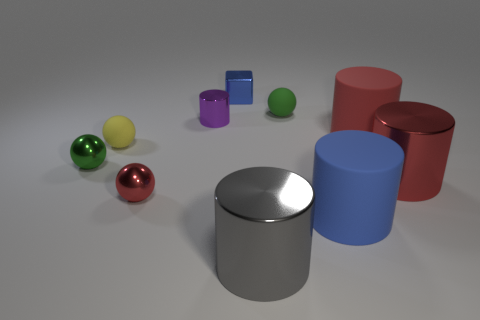How many objects are either large objects or red objects behind the big red shiny thing?
Offer a terse response. 4. What is the material of the purple cylinder that is the same size as the cube?
Offer a very short reply. Metal. Is the material of the yellow sphere the same as the red sphere?
Your response must be concise. No. There is a cylinder that is both behind the big red metallic cylinder and in front of the small purple metallic object; what is its color?
Your answer should be compact. Red. There is a small object that is left of the tiny yellow thing; does it have the same color as the small cube?
Provide a short and direct response. No. What shape is the green rubber object that is the same size as the blue metallic object?
Keep it short and to the point. Sphere. What number of other objects are there of the same color as the tiny cylinder?
Give a very brief answer. 0. What number of other objects are there of the same material as the gray cylinder?
Make the answer very short. 5. Is the size of the yellow object the same as the green ball right of the purple metallic object?
Provide a short and direct response. Yes. What color is the cube?
Make the answer very short. Blue. 